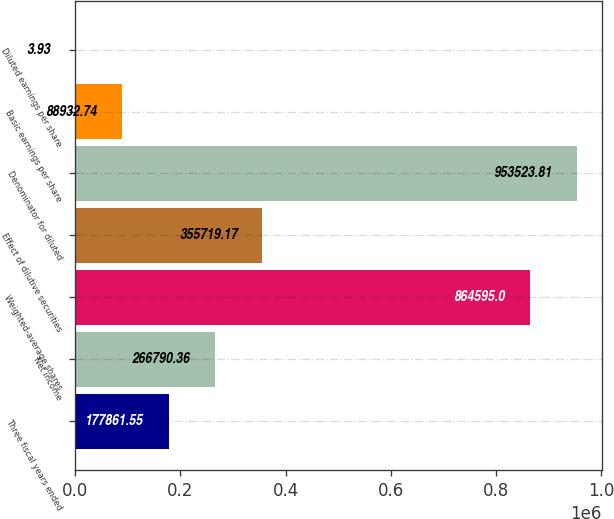<chart> <loc_0><loc_0><loc_500><loc_500><bar_chart><fcel>Three fiscal years ended<fcel>Net income<fcel>Weighted-average shares<fcel>Effect of dilutive securities<fcel>Denominator for diluted<fcel>Basic earnings per share<fcel>Diluted earnings per share<nl><fcel>177862<fcel>266790<fcel>864595<fcel>355719<fcel>953524<fcel>88932.7<fcel>3.93<nl></chart> 